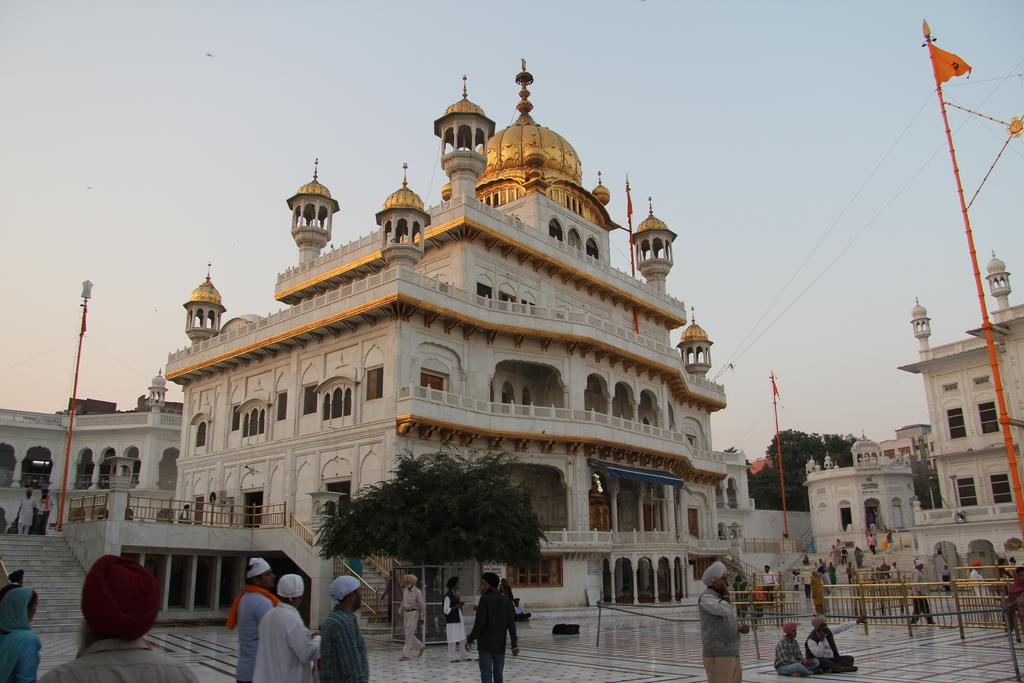What can be seen at the bottom of the image? There are people at the bottom of the image. What is located in the middle of the image? There are buildings and trees in the middle of the image. What is visible at the top of the image? The sky is visible at the top of the image. What type of ship can be seen sailing in the sky in the image? There is no ship present in the image; it only features people, buildings, trees, and the sky. What flavor of eggnog is being consumed by the people in the image? There is no eggnog present in the image, nor is there any indication that the people are consuming any beverages. 